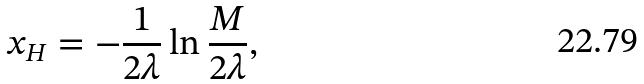<formula> <loc_0><loc_0><loc_500><loc_500>x _ { H } = - \frac { 1 } { 2 \lambda } \ln \frac { M } { 2 \lambda } ,</formula> 